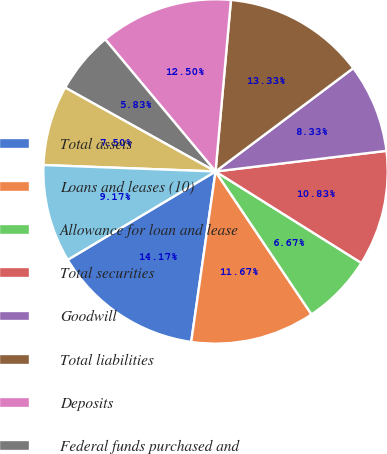Convert chart to OTSL. <chart><loc_0><loc_0><loc_500><loc_500><pie_chart><fcel>Total assets<fcel>Loans and leases (10)<fcel>Allowance for loan and lease<fcel>Total securities<fcel>Goodwill<fcel>Total liabilities<fcel>Deposits<fcel>Federal funds purchased and<fcel>Other short-term borrowed<fcel>Long-term borrowed funds<nl><fcel>14.17%<fcel>11.67%<fcel>6.67%<fcel>10.83%<fcel>8.33%<fcel>13.33%<fcel>12.5%<fcel>5.83%<fcel>7.5%<fcel>9.17%<nl></chart> 